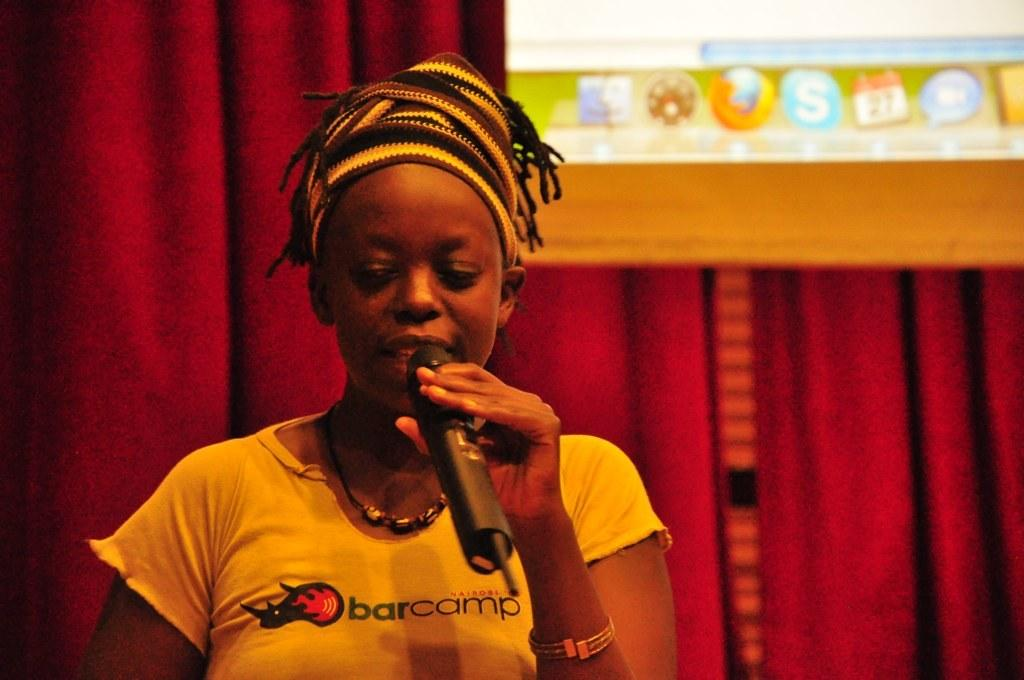What can be seen in the image? There is a person in the image. What is the person wearing? The person is wearing a yellow T-shirt, a chain, and headwear. What is the person holding? The person is holding a microphone. What can be seen in the background of the image? There is a projector screen and maroon-colored curtains in the background of the image. What color crayon is the person using to draw on the side of the projector screen? There is no crayon or drawing present in the image; the person is holding a microphone and standing in front of a projector screen with maroon-colored curtains in the background. 